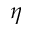<formula> <loc_0><loc_0><loc_500><loc_500>\eta</formula> 